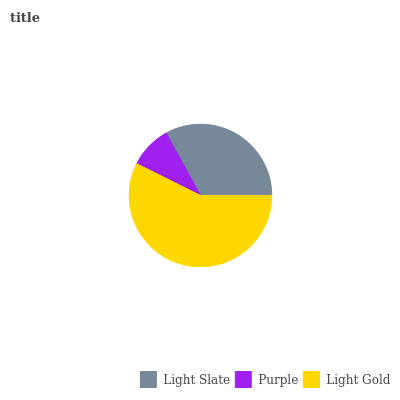Is Purple the minimum?
Answer yes or no. Yes. Is Light Gold the maximum?
Answer yes or no. Yes. Is Light Gold the minimum?
Answer yes or no. No. Is Purple the maximum?
Answer yes or no. No. Is Light Gold greater than Purple?
Answer yes or no. Yes. Is Purple less than Light Gold?
Answer yes or no. Yes. Is Purple greater than Light Gold?
Answer yes or no. No. Is Light Gold less than Purple?
Answer yes or no. No. Is Light Slate the high median?
Answer yes or no. Yes. Is Light Slate the low median?
Answer yes or no. Yes. Is Purple the high median?
Answer yes or no. No. Is Purple the low median?
Answer yes or no. No. 